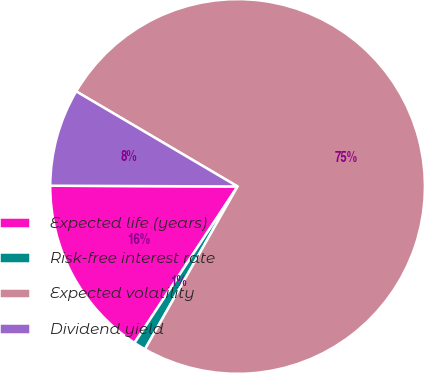Convert chart. <chart><loc_0><loc_0><loc_500><loc_500><pie_chart><fcel>Expected life (years)<fcel>Risk-free interest rate<fcel>Expected volatility<fcel>Dividend yield<nl><fcel>15.79%<fcel>1.04%<fcel>74.76%<fcel>8.41%<nl></chart> 